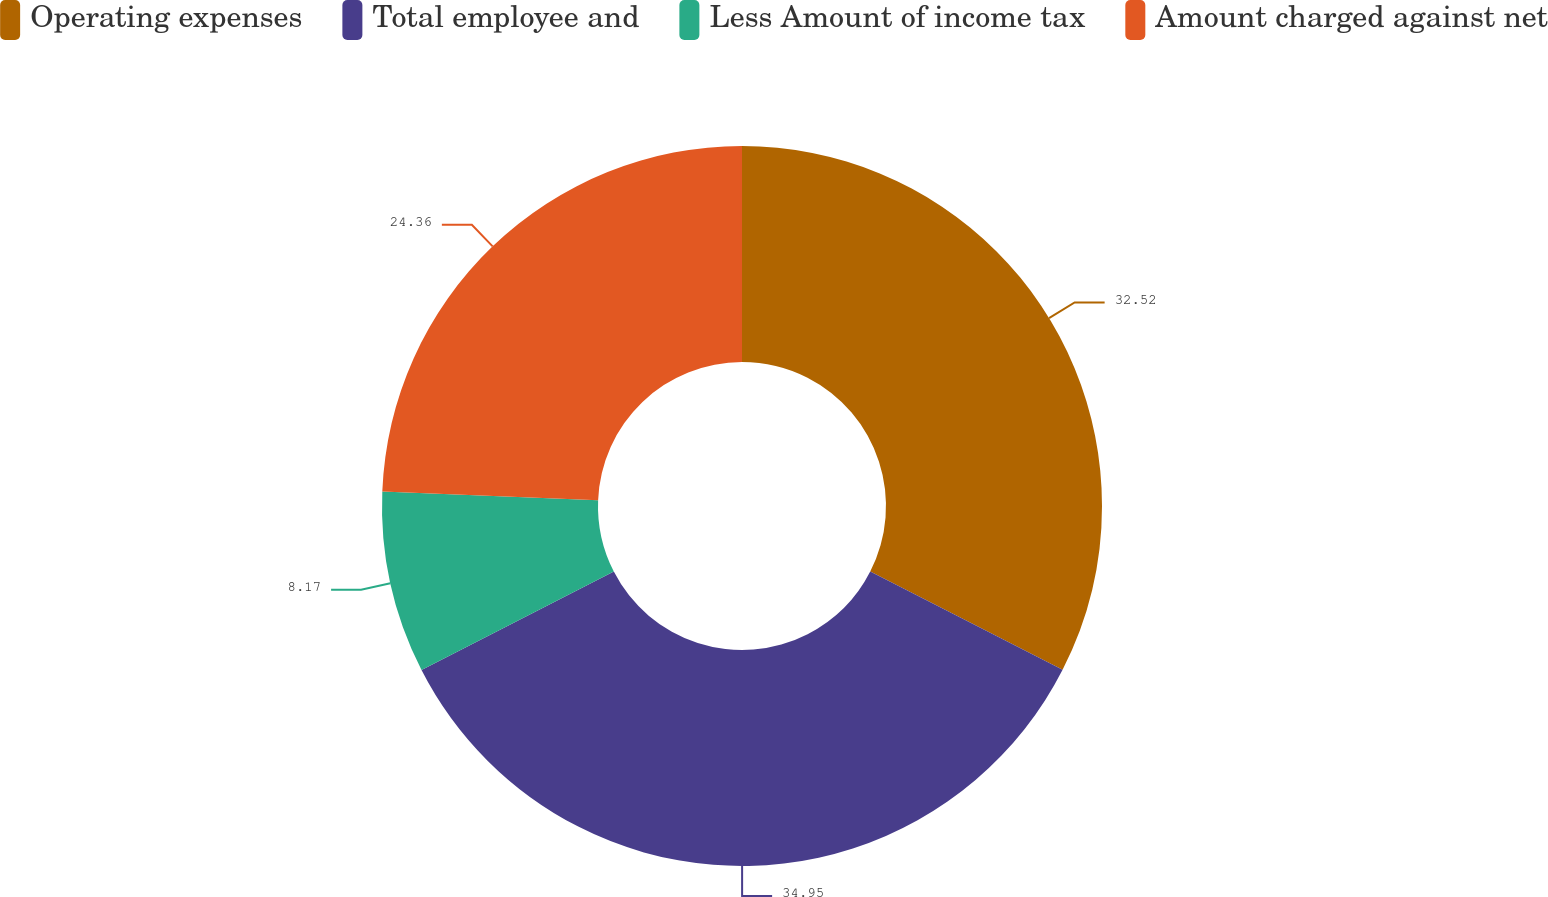Convert chart. <chart><loc_0><loc_0><loc_500><loc_500><pie_chart><fcel>Operating expenses<fcel>Total employee and<fcel>Less Amount of income tax<fcel>Amount charged against net<nl><fcel>32.52%<fcel>34.96%<fcel>8.17%<fcel>24.36%<nl></chart> 